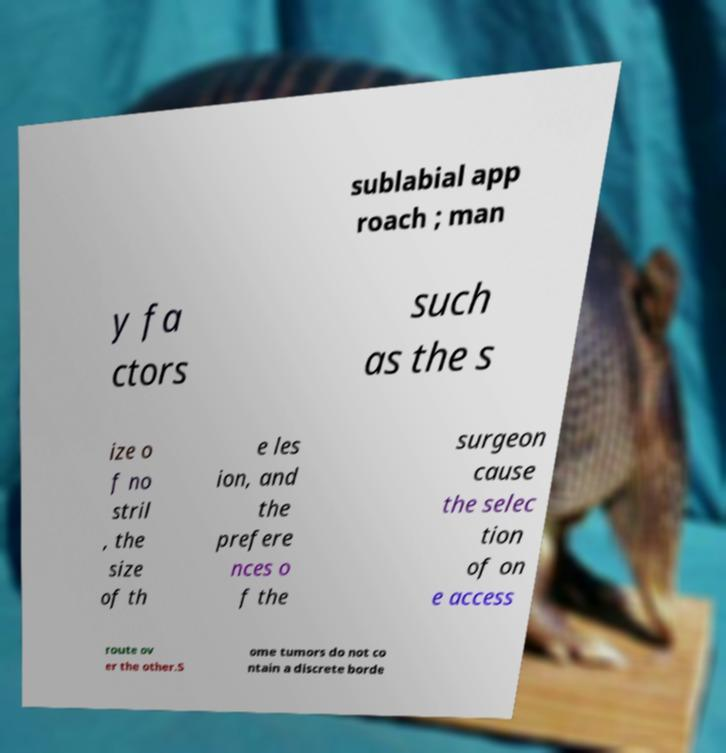There's text embedded in this image that I need extracted. Can you transcribe it verbatim? sublabial app roach ; man y fa ctors such as the s ize o f no stril , the size of th e les ion, and the prefere nces o f the surgeon cause the selec tion of on e access route ov er the other.S ome tumors do not co ntain a discrete borde 